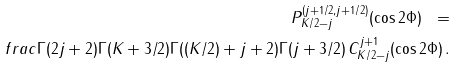<formula> <loc_0><loc_0><loc_500><loc_500>P ^ { ( j + 1 / 2 , j + 1 / 2 ) } _ { K / 2 - j } ( \cos 2 \Phi ) \ = \\ f r a c { \Gamma ( 2 j + 2 ) \Gamma ( K + 3 / 2 ) } { \Gamma ( ( K / 2 ) + j + 2 ) \Gamma ( j + 3 / 2 ) } \, C ^ { j + 1 } _ { K / 2 - j } ( \cos 2 \Phi ) \, .</formula> 